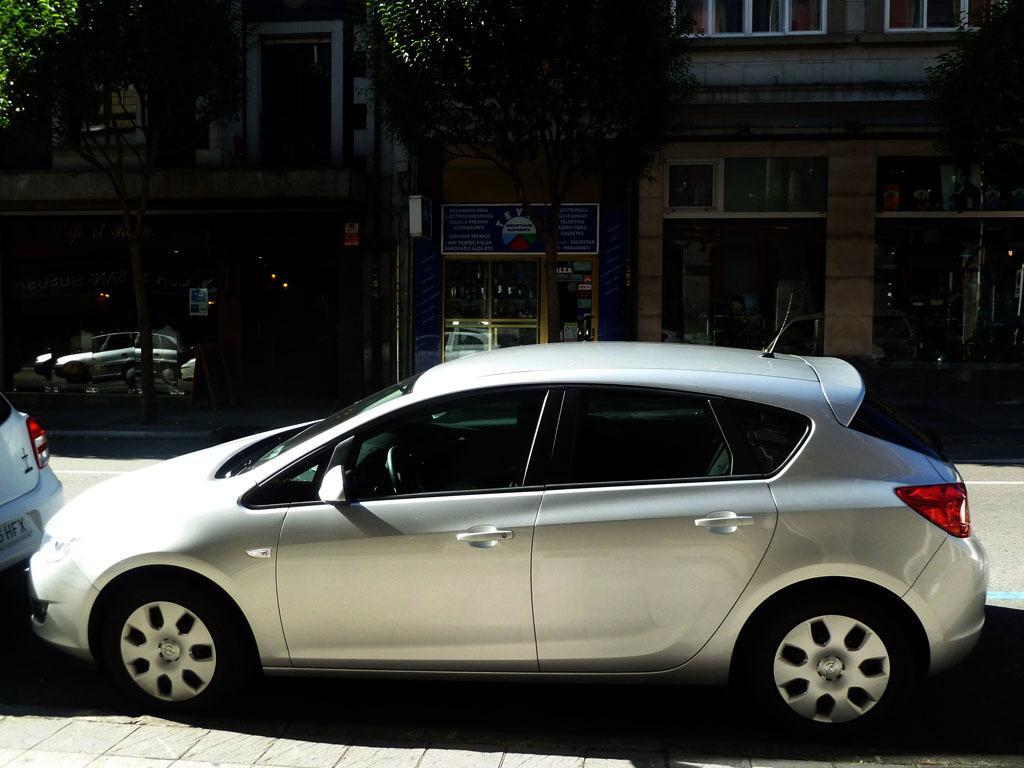Can you describe this image briefly? In this image we can see two cars which are parked on the road and in the background of the image there are some trees and buildings. 